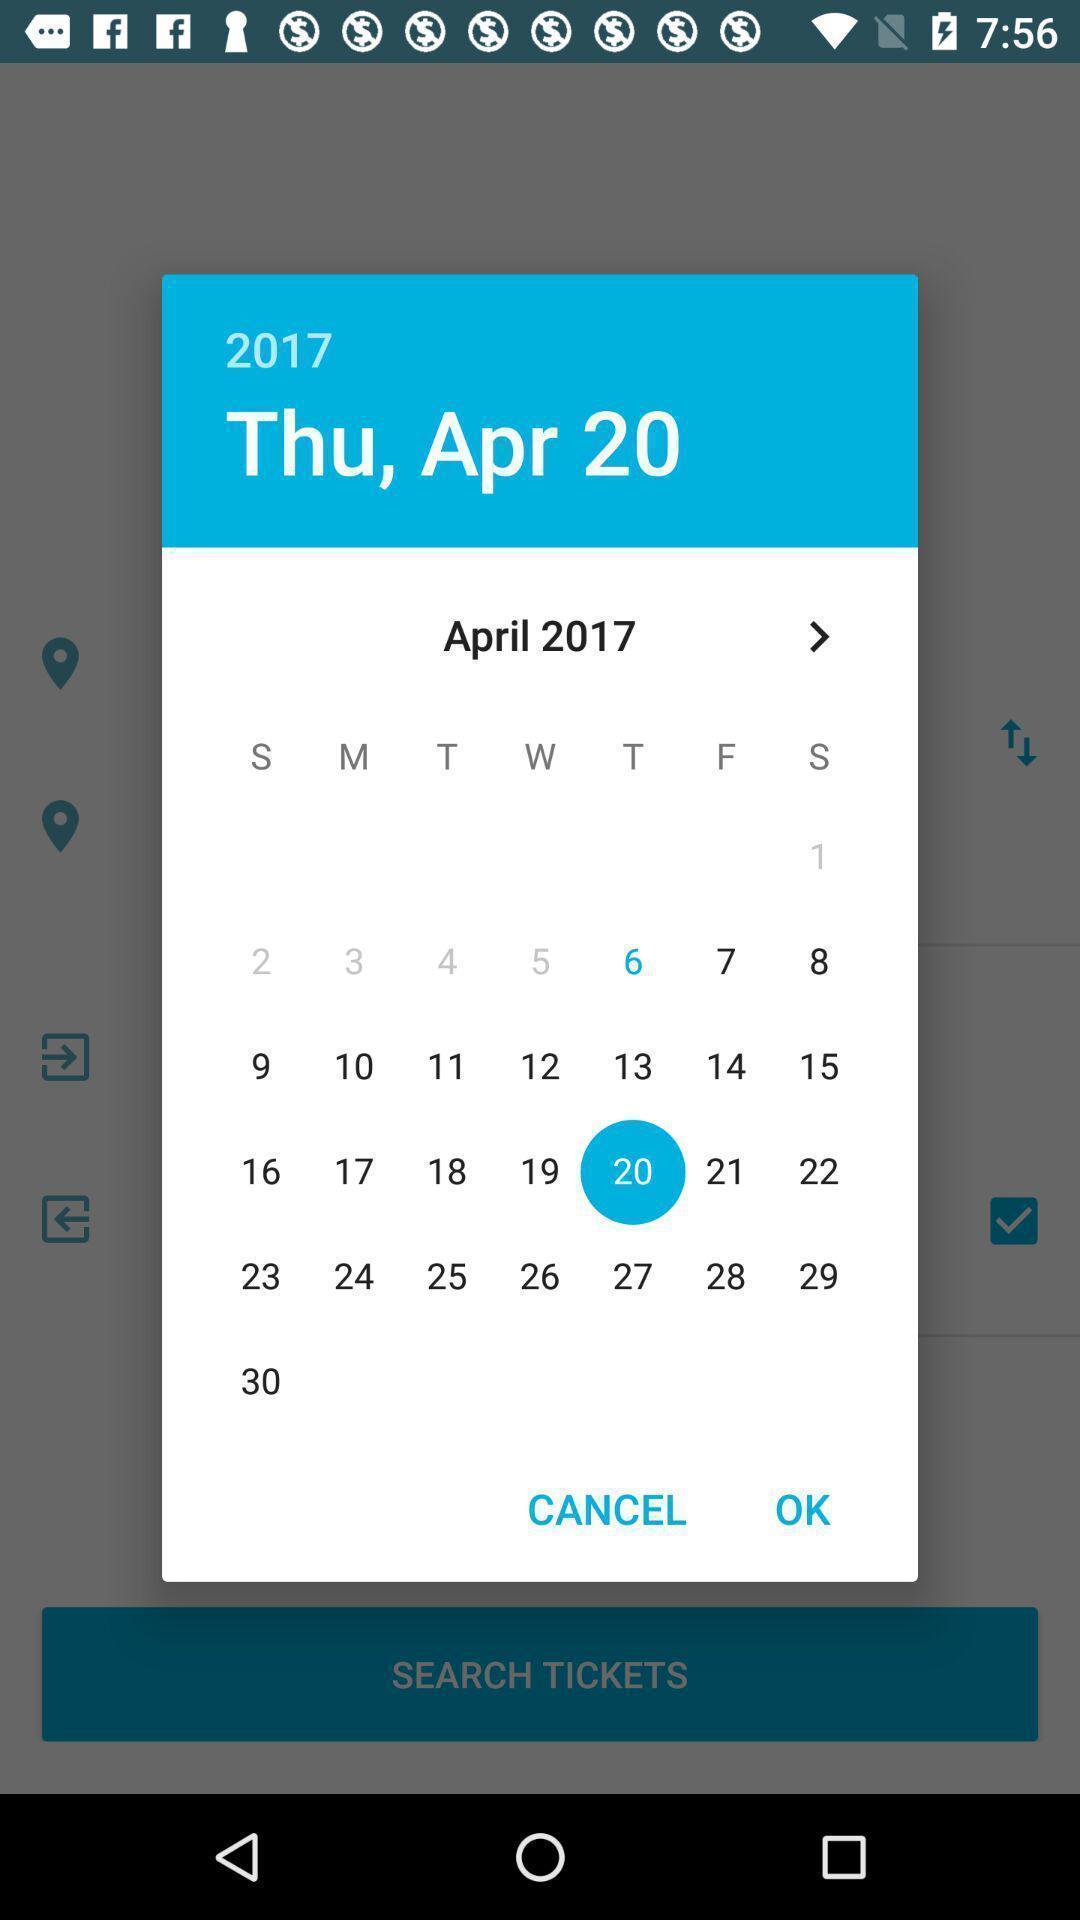Describe this image in words. Pop up showing dates in calendar. 